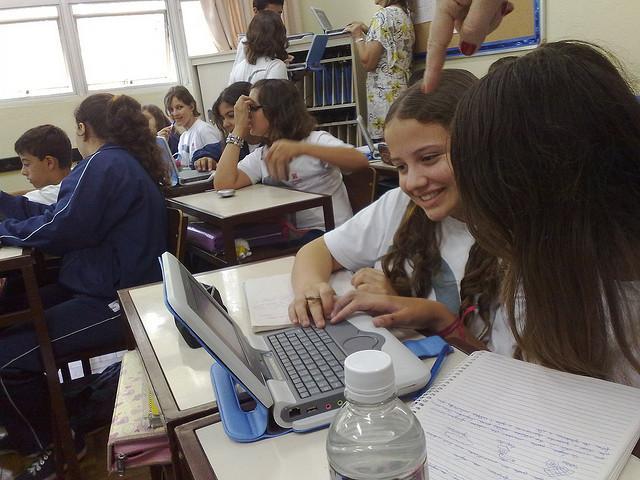Who is probably pointing above the students?

Choices:
A) teacher
B) janitor
C) student
D) parent teacher 